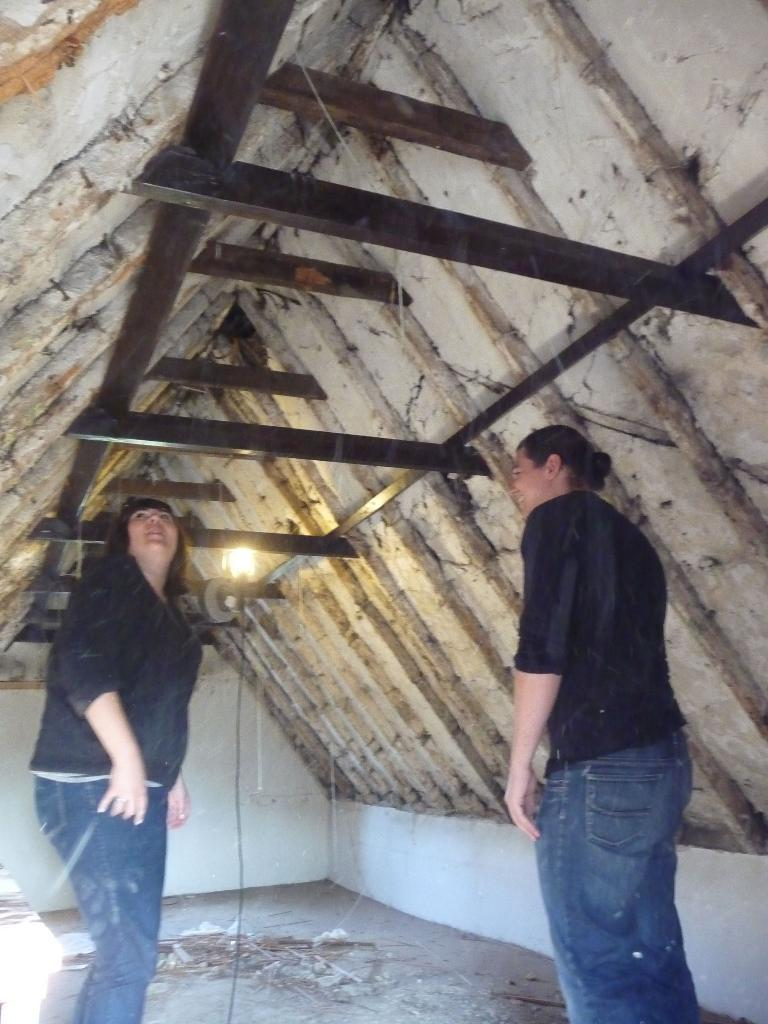How many people are in the image? There are two persons standing in the image. What can be seen in the background of the image? There is a roof visible in the background of the image. Can you describe the lighting in the image? Yes, there is light in the image. What type of plot is being cultivated in the image? There is no plot visible in the image; it only features two persons and a roof in the background. 